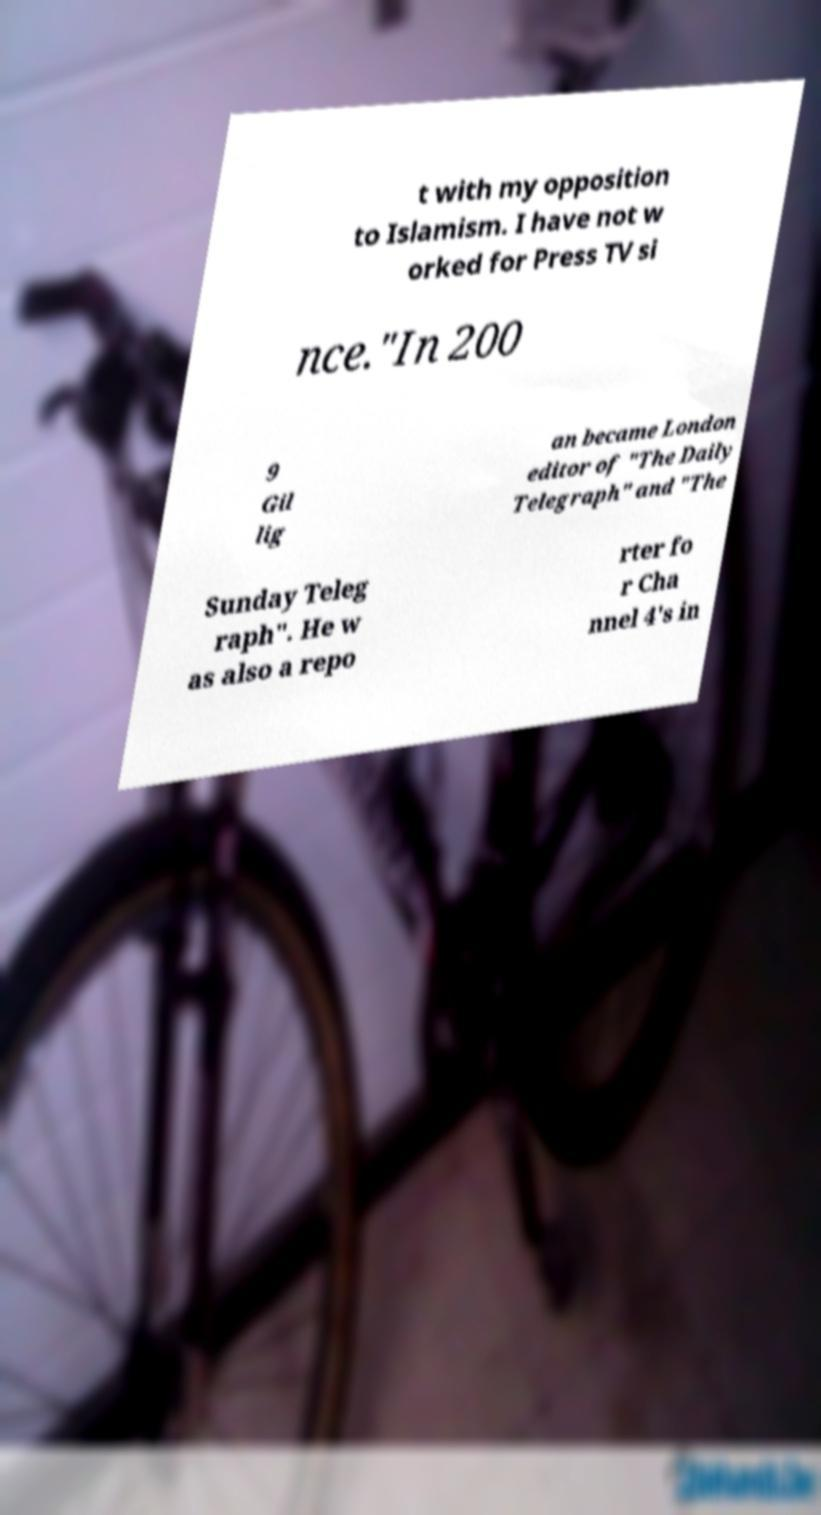Please identify and transcribe the text found in this image. t with my opposition to Islamism. I have not w orked for Press TV si nce."In 200 9 Gil lig an became London editor of "The Daily Telegraph" and "The Sunday Teleg raph". He w as also a repo rter fo r Cha nnel 4's in 